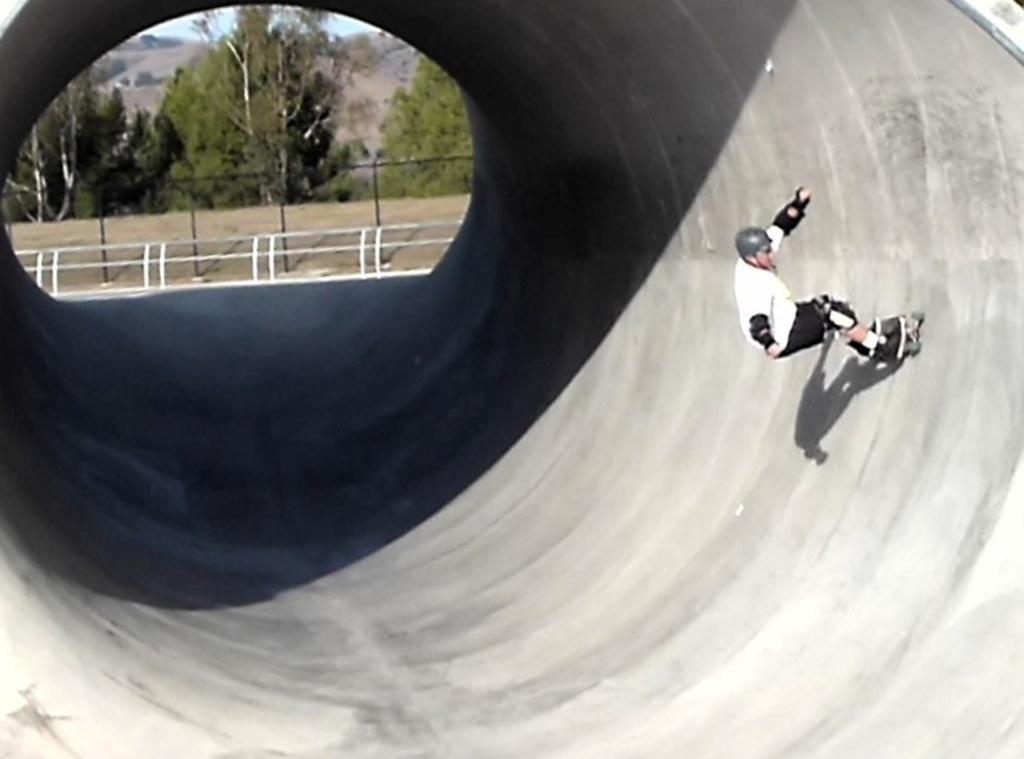What type of vegetation can be seen in the image? There are trees in the image. What activity is the person in the image engaged in? The person is standing on a skateboard. What safety gear is the person wearing? The person is wearing a helmet. Where is the helmet positioned on the person? The helmet is on the person's head. What type of barrier is present in the image? There is a metal fence in the image. What type of glove is the person wearing while skateboarding in the image? There is no glove visible in the image; the person is only wearing a helmet. What team is the person representing while skateboarding in the image? There is no indication of a team in the image; the person is simply standing on a skateboard. 